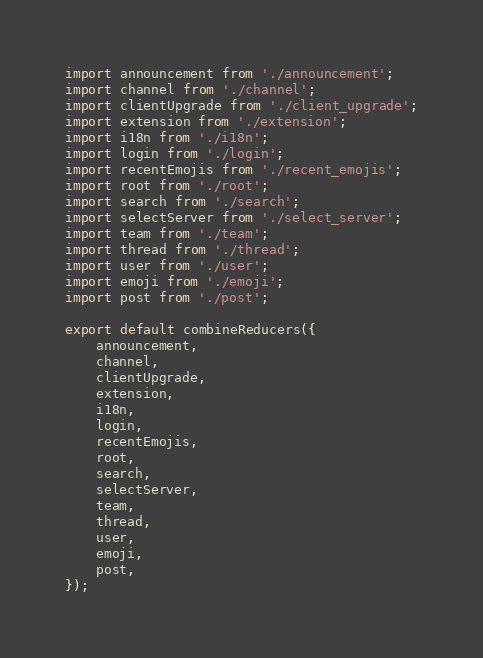Convert code to text. <code><loc_0><loc_0><loc_500><loc_500><_JavaScript_>
import announcement from './announcement';
import channel from './channel';
import clientUpgrade from './client_upgrade';
import extension from './extension';
import i18n from './i18n';
import login from './login';
import recentEmojis from './recent_emojis';
import root from './root';
import search from './search';
import selectServer from './select_server';
import team from './team';
import thread from './thread';
import user from './user';
import emoji from './emoji';
import post from './post';

export default combineReducers({
    announcement,
    channel,
    clientUpgrade,
    extension,
    i18n,
    login,
    recentEmojis,
    root,
    search,
    selectServer,
    team,
    thread,
    user,
    emoji,
    post,
});
</code> 